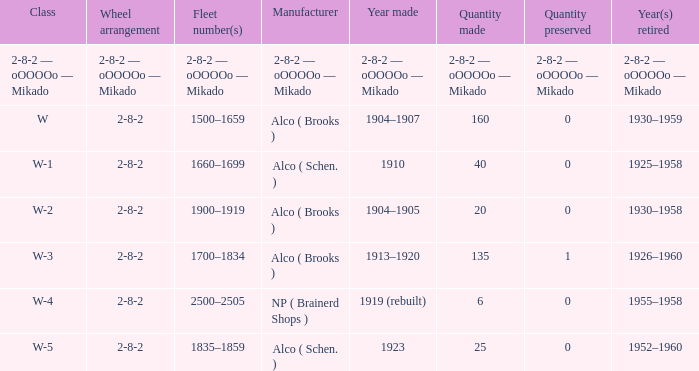What is the amount conserved to the locomotive with a number composed of 6? 0.0. 